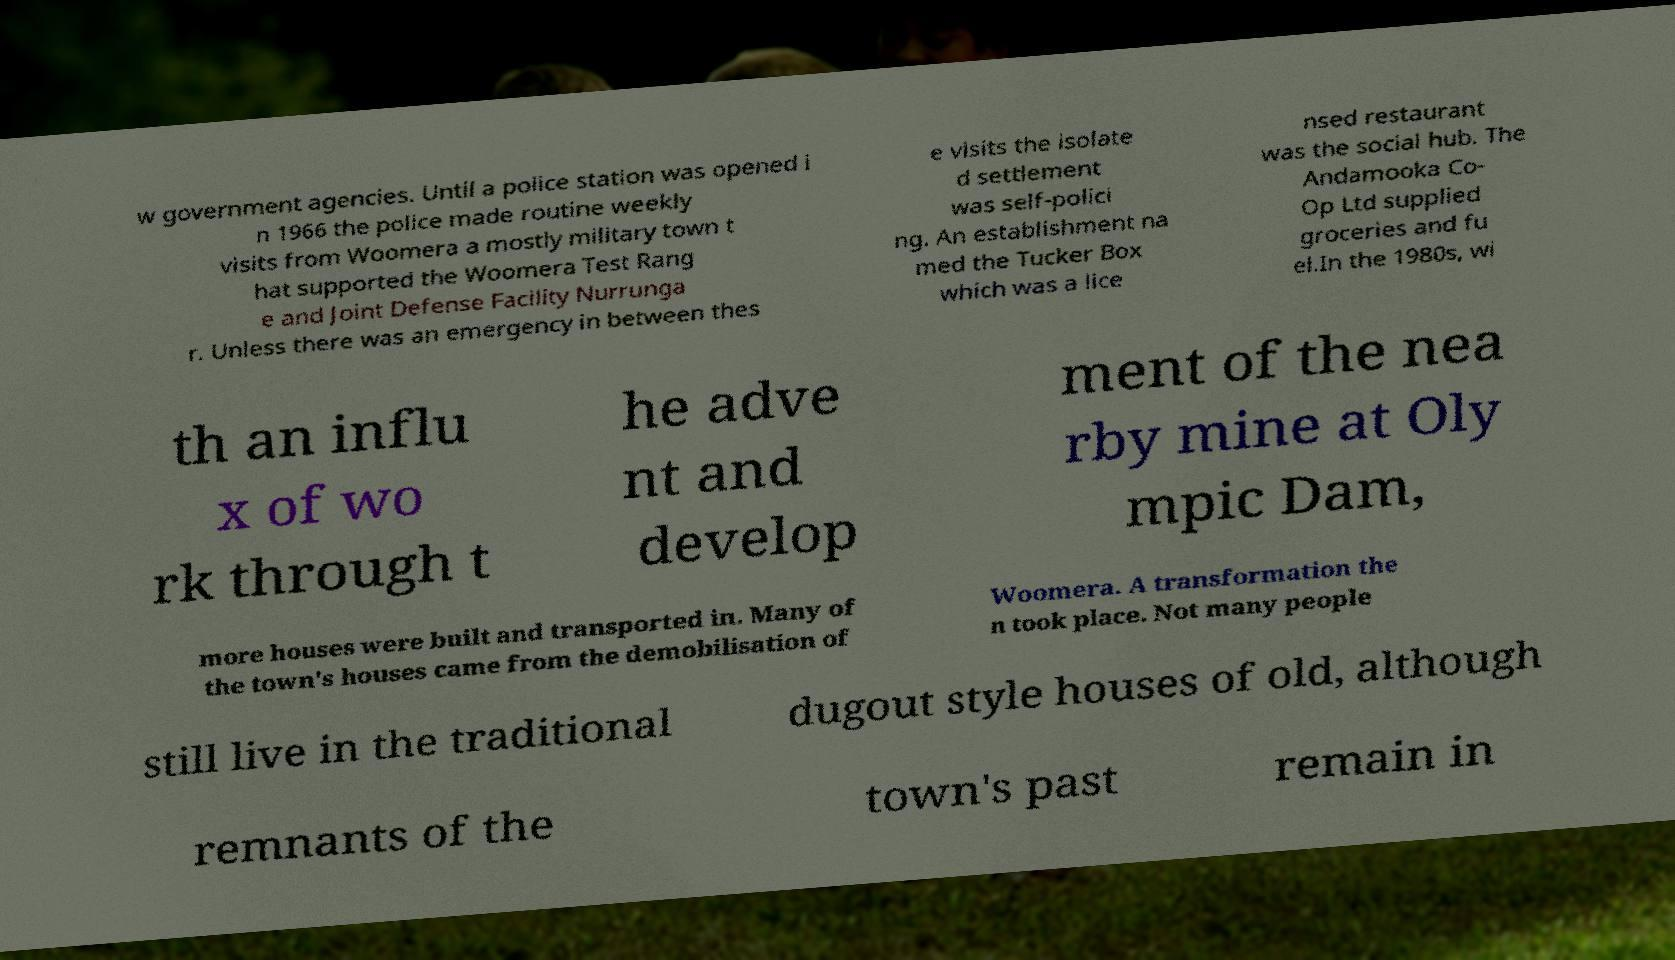For documentation purposes, I need the text within this image transcribed. Could you provide that? w government agencies. Until a police station was opened i n 1966 the police made routine weekly visits from Woomera a mostly military town t hat supported the Woomera Test Rang e and Joint Defense Facility Nurrunga r. Unless there was an emergency in between thes e visits the isolate d settlement was self-polici ng. An establishment na med the Tucker Box which was a lice nsed restaurant was the social hub. The Andamooka Co- Op Ltd supplied groceries and fu el.In the 1980s, wi th an influ x of wo rk through t he adve nt and develop ment of the nea rby mine at Oly mpic Dam, more houses were built and transported in. Many of the town's houses came from the demobilisation of Woomera. A transformation the n took place. Not many people still live in the traditional dugout style houses of old, although remnants of the town's past remain in 